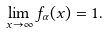Convert formula to latex. <formula><loc_0><loc_0><loc_500><loc_500>\lim _ { x \to \infty } f _ { \alpha } ( x ) = 1 .</formula> 